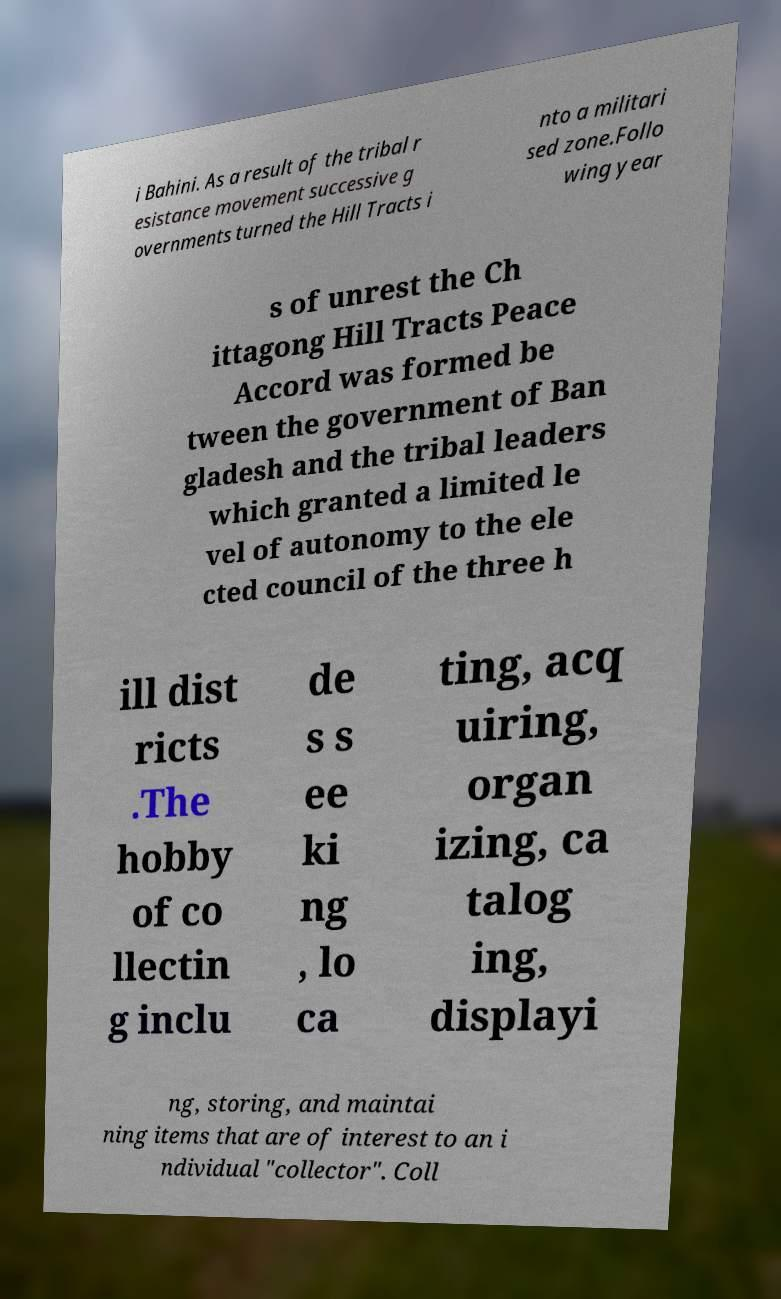There's text embedded in this image that I need extracted. Can you transcribe it verbatim? i Bahini. As a result of the tribal r esistance movement successive g overnments turned the Hill Tracts i nto a militari sed zone.Follo wing year s of unrest the Ch ittagong Hill Tracts Peace Accord was formed be tween the government of Ban gladesh and the tribal leaders which granted a limited le vel of autonomy to the ele cted council of the three h ill dist ricts .The hobby of co llectin g inclu de s s ee ki ng , lo ca ting, acq uiring, organ izing, ca talog ing, displayi ng, storing, and maintai ning items that are of interest to an i ndividual "collector". Coll 